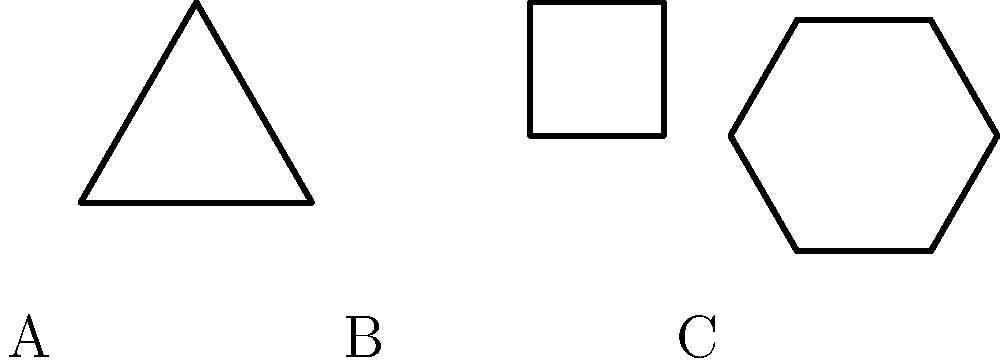Consider the three prison cell layouts shown above: a triangular cell (A), a square cell (B), and a hexagonal cell (C). Which of these layouts has the highest order symmetry group, potentially offering the most opportunities for an innocent inmate to contemplate the flaws in the justice system? To determine which layout has the highest order symmetry group, we need to analyze each shape:

1. Triangle (Layout A):
   - Rotational symmetry: 3-fold (120° rotations)
   - Reflection symmetry: 3 lines of reflection
   - Total symmetries: 6
   - Symmetry group: $D_3$ (Dihedral group of order 6)

2. Square (Layout B):
   - Rotational symmetry: 4-fold (90° rotations)
   - Reflection symmetry: 4 lines of reflection
   - Total symmetries: 8
   - Symmetry group: $D_4$ (Dihedral group of order 8)

3. Hexagon (Layout C):
   - Rotational symmetry: 6-fold (60° rotations)
   - Reflection symmetry: 6 lines of reflection
   - Total symmetries: 12
   - Symmetry group: $D_6$ (Dihedral group of order 12)

The order of a symmetry group is the total number of symmetries. Therefore, the hexagonal cell (Layout C) has the highest order symmetry group with 12 elements.

For a wrongly accused individual, the hexagonal cell offers the most symmetrical environment, potentially providing more visual cues for introspection about the flaws in the justice system.
Answer: Layout C (hexagonal cell) 